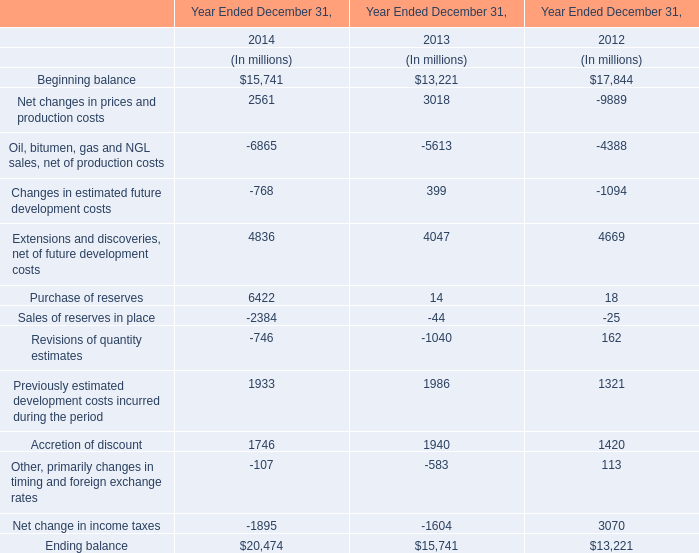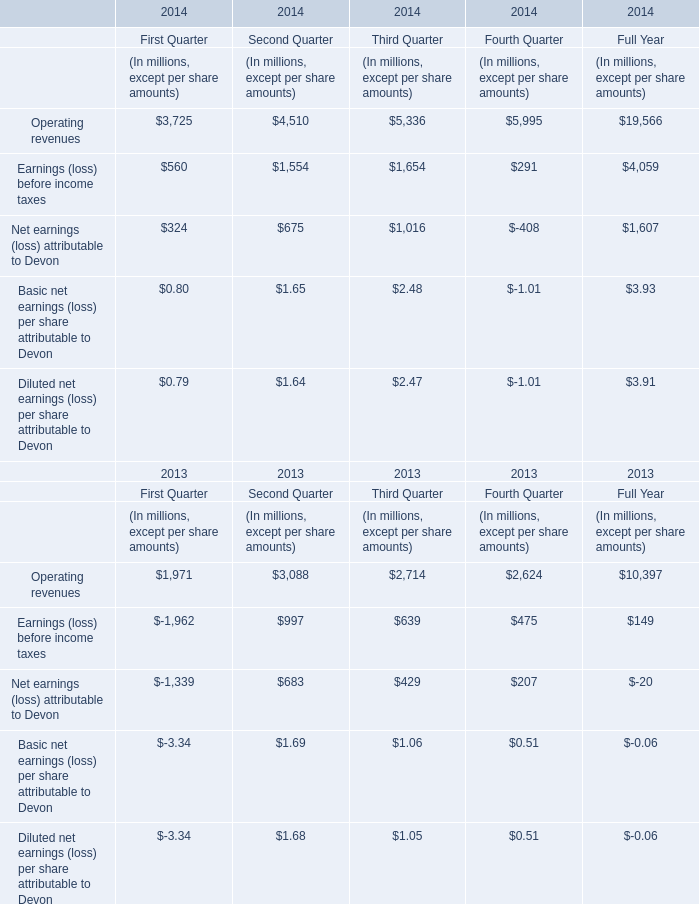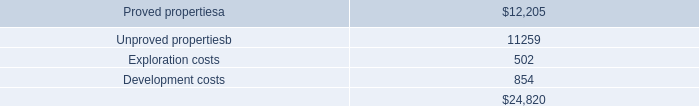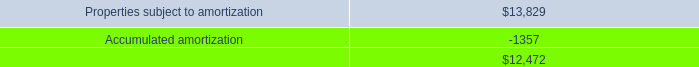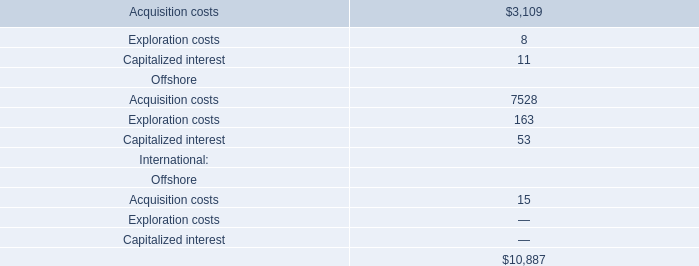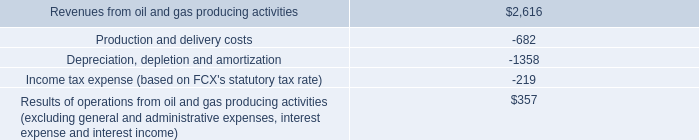If operating revenue develops with the same increasing rate in 2014, what will it reach in 2015? (in million) 
Computations: ((((19566 - 10397) / 10397) + 1) * 19566)
Answer: 36821.0403. 